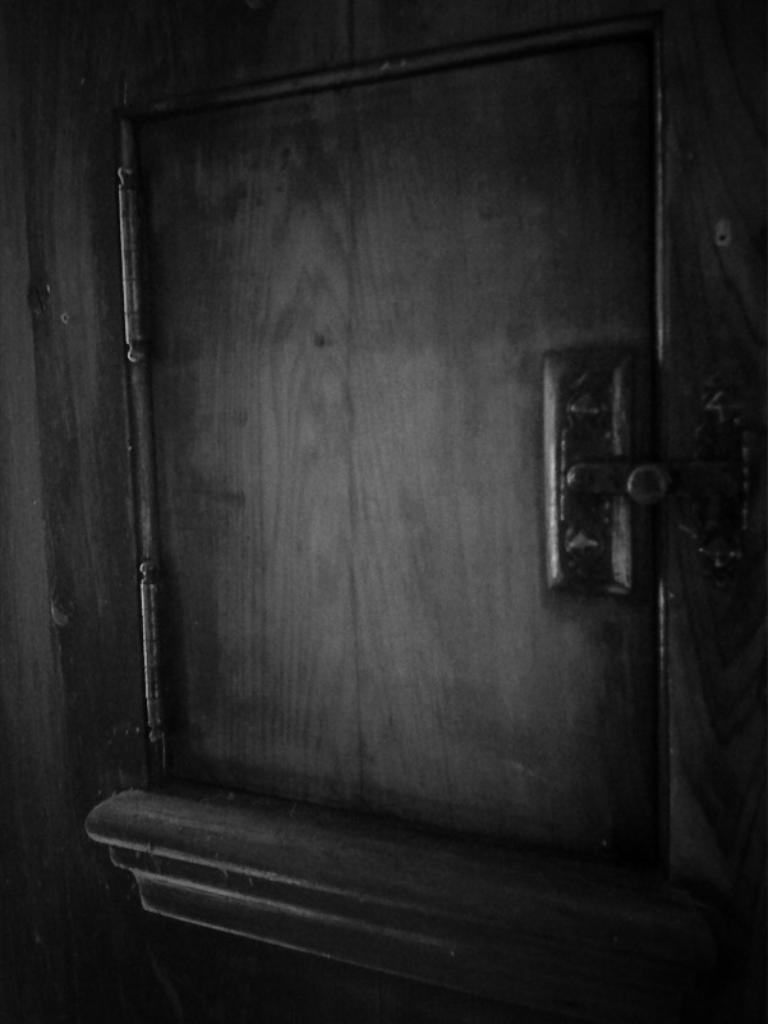What is the color scheme of the image? The image is black and white. What can be seen in the image? There is a small door in the image. What type of knife is being used to make noise in the image? There is no knife or noise present in the image; it only features a small door in a black and white setting. 